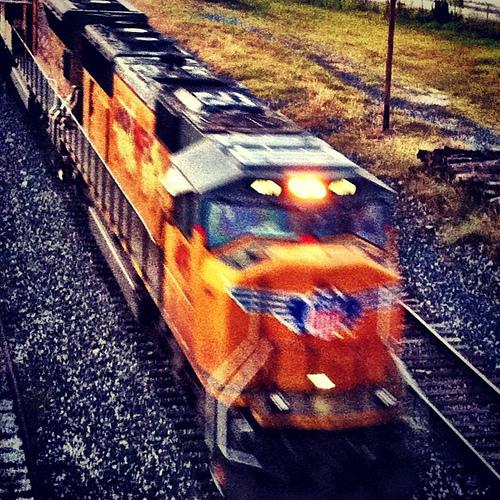Count and state the number of rocks present in the image. There are 9 instances of black and silver rocks on the ground. How many train tracks are visible in the image? There are three instances of train tracks in the image. Please describe the vegetation present in the image. There is a green area with grass and dirt, and a thin wooden tree trunk next to the train track. Evaluate the quality of the train's headlights. The headlight of the train is bright and glowing, illuminating the path in front of the train. What is the sentiment or mood conveyed by the image? The image conveys a sense of motion and industrial activity, as the train speeds through its natural surroundings. Analyze the interaction between the train and its surroundings. The train is speeding along the track with its head light glowing, creating a contrast between the motion and the still nature of the surrounding rocks, grass, and gravel. What is the primary object in the image and its action? A bright orange train is in motion passing along the train tracks. In a brief sentence, explain the setting of the image. The image shows a speeding orange train on the tracks surrounded by rocks, grass, and gravel. Identify the primary mode of transportation present in the image. The primary mode of transportation is a train. What type of vehicle is on the train track? Train Can you spot the group of people waiting for the train on the platform? They are all standing near a bench. There is no mention of people or a platform in the image details, or any mention of a bench. This instruction is misleading because it introduces elements that do not exist in the image. Multi-Choice VQA: What is the color of the train in the image? a) Red b) Orange c) Blue d) Green b) Orange Is there a wooden tree trunk in the image? What are its dimensions? Yes, there is a thin wooden tree trunk extending from the top to the ground level. List the different types of objects near the train track in the image. Rocks, grass, dirt, utility pole, crushed stones, logs of wood Which part of the train appears to be in motion? Front portion of the engine Can you identify the impressive graffiti art on the side of the train? It's quite a colorful and creative piece of art. There is no mention of graffiti or art in the image details. This instruction is misleading because it introduces an element (graffiti) that isn't present in the image and makes the viewer search for non-existent art. What kind of vehicle is in motion in the image? A large orange train Please notice how the birds are flying above the train, forming an interesting pattern. Isn't it fascinating? There is no mention of birds or flying objects in the image details. This instruction is misleading because it introduces an element (birds) that isn't present in the image. List the main components of the train that are visible in this image. Engine, headlight, front windshield, lights, front portion of the engine, logo on front train car, front windows of train car How many windows can be seen on the front of the train car? Two front windows What type of surface is surrounding the train tracks? Gravel Identify and describe the object that supports the utility pole. Pole in the ground, extending from ground to the top of the image Describe the scene involving the train and its surroundings. A bright orange train is running on a track surrounded by gravel, grass, green vegetation, and black and silver rocks, with a utility pole nearby. What are the colors of the rocks on the ground? Black and silver What is the light source in the image? Headlight of the train and lights on front of the train What is the specific function of the headlight on the train? To provide bright light for visibility while in motion Can you see the small train station building next to the tracks? It's quite a charming and quaint structure. There is no mention of a train station building in the image details. This instruction is misleading because it introduces an element (a train station building) that does not exist in the image and can cause confusion for the viewer. Find the dog playing with a ball near the green grass patch beside the train tracks. The dog is adorable, isn't it? There is no mention of a dog or a ball in the image details. This instruction is misleading because it introduces elements (a dog and a ball) that do not exist in the image. What type of logo is on the front of the train? Blurry white and blue logo Which activity can be deduced from the scene involving the train and objects around it? Train traveling down the tracks, with objects like rocks and utility poles near the track Where are the train tracks in the image? Between gravel and grass areas, curving away from the viewer What natural elements can be found next to the train track? Specify their colors. Grass (green), dirt (brown), and rocks (black and silver) Is there a logo on the front of the train? If yes, what colors are present? Yes, there is a blurry white and blue logo on the front of the train. What do the train tracks look like? Black train tracks, curving away from the viewer Don't you think the large tree with red flowers next to the train track adds a beautiful splash of color to the scene? There is no mention of a large tree or red flowers in the image details. This instruction is misleading because it introduces elements (a tree with red flowers) that are not present in the image and may cause confusion. 